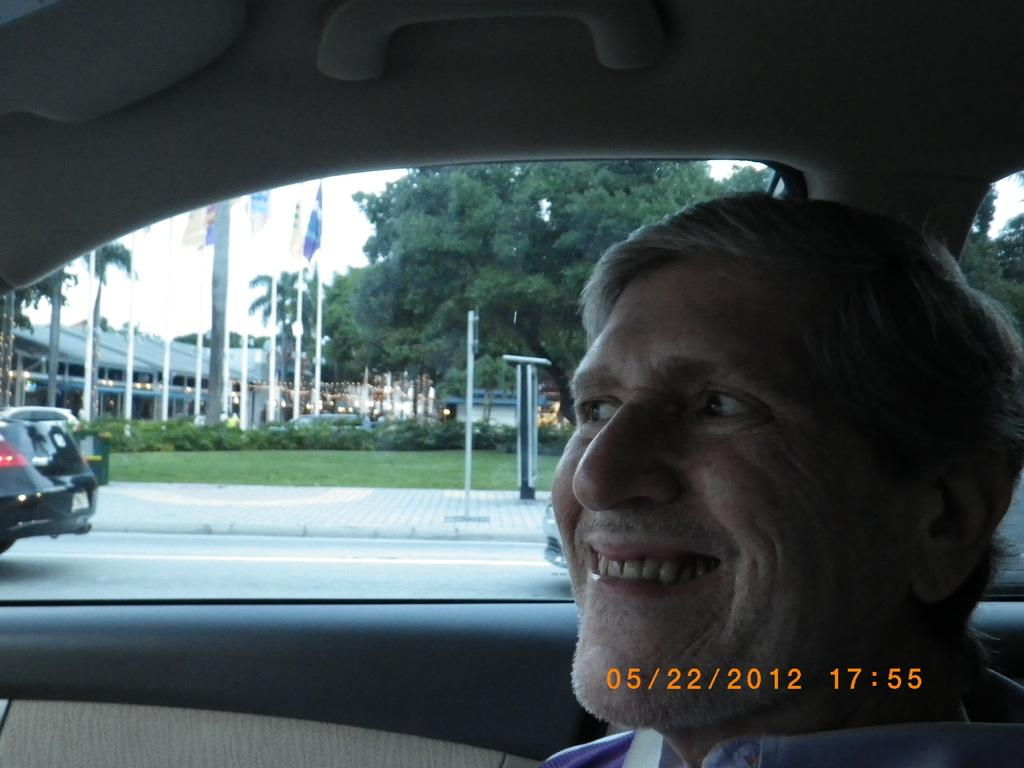What is the man in the image doing? The man is sitting in a car and smiling. What can be seen on the road beside the car? Cars are moving on the road beside the car. What type of structures are visible in the image? There are buildings visible in the image. What additional elements can be seen in the image? Flags and trees are present in the image. What type of bait is the man using to catch fish in the image? There is no indication in the image that the man is fishing or using bait; he is sitting in a car and smiling. 